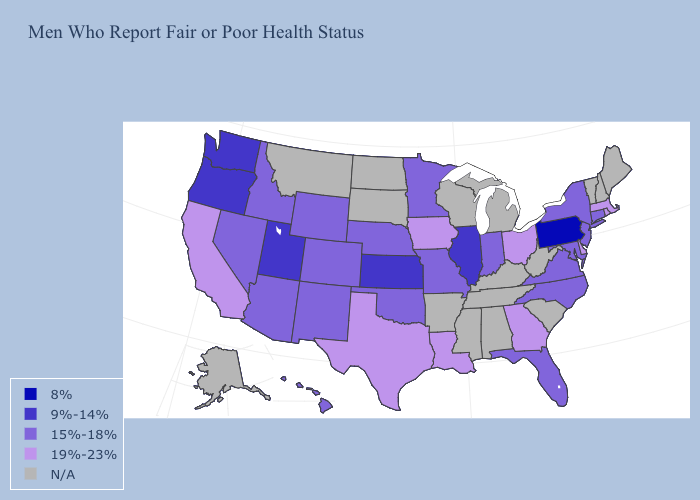Name the states that have a value in the range 8%?
Give a very brief answer. Pennsylvania. Among the states that border Iowa , which have the lowest value?
Write a very short answer. Illinois. Name the states that have a value in the range N/A?
Answer briefly. Alabama, Alaska, Arkansas, Kentucky, Maine, Michigan, Mississippi, Montana, New Hampshire, North Dakota, South Carolina, South Dakota, Tennessee, Vermont, West Virginia, Wisconsin. What is the value of Iowa?
Give a very brief answer. 19%-23%. Does Texas have the highest value in the South?
Write a very short answer. Yes. Among the states that border Virginia , which have the highest value?
Short answer required. Maryland, North Carolina. Which states have the lowest value in the USA?
Answer briefly. Pennsylvania. Does the map have missing data?
Short answer required. Yes. What is the lowest value in the USA?
Keep it brief. 8%. Does Pennsylvania have the lowest value in the USA?
Answer briefly. Yes. Name the states that have a value in the range 8%?
Be succinct. Pennsylvania. What is the value of Kentucky?
Concise answer only. N/A. Does the map have missing data?
Concise answer only. Yes. 